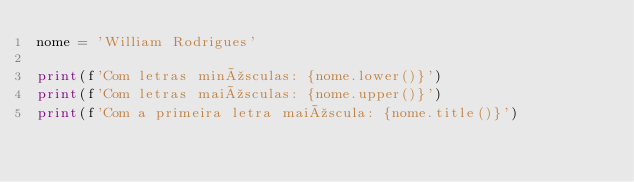Convert code to text. <code><loc_0><loc_0><loc_500><loc_500><_Python_>nome = 'William Rodrigues'

print(f'Com letras minúsculas: {nome.lower()}')
print(f'Com letras maiúsculas: {nome.upper()}')
print(f'Com a primeira letra maiúscula: {nome.title()}')
</code> 